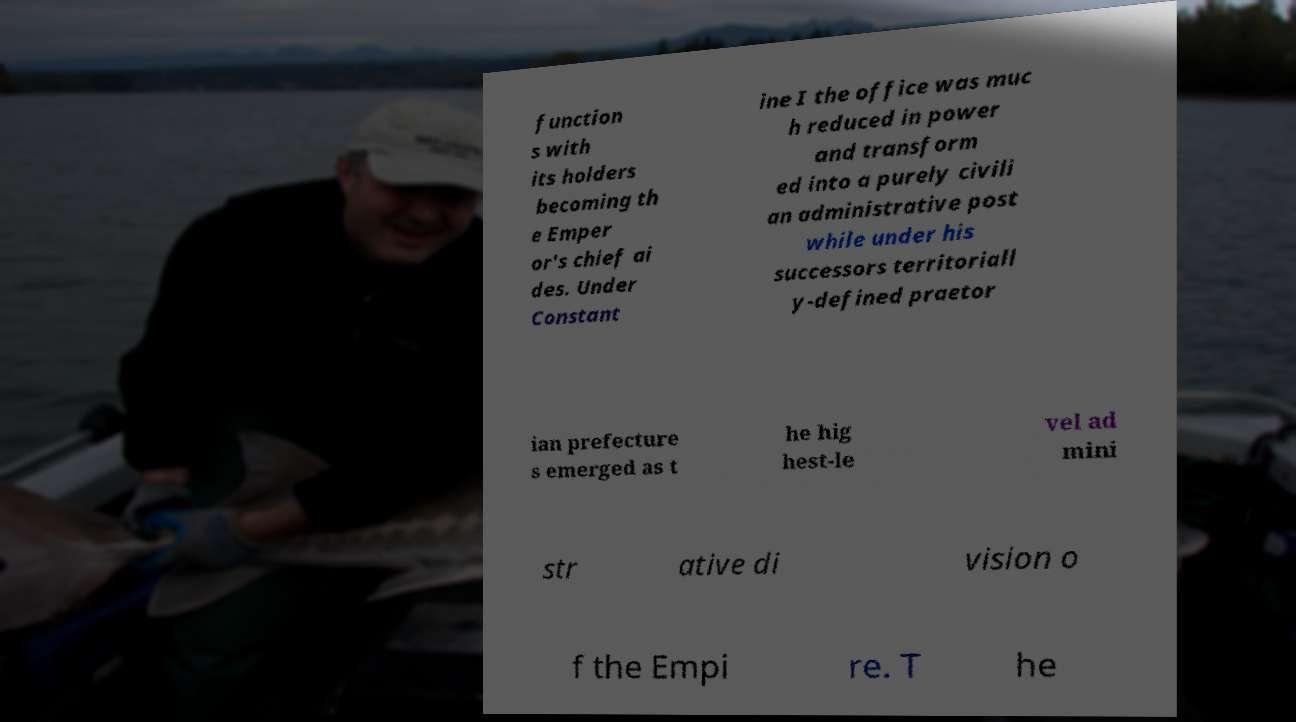Can you accurately transcribe the text from the provided image for me? function s with its holders becoming th e Emper or's chief ai des. Under Constant ine I the office was muc h reduced in power and transform ed into a purely civili an administrative post while under his successors territoriall y-defined praetor ian prefecture s emerged as t he hig hest-le vel ad mini str ative di vision o f the Empi re. T he 